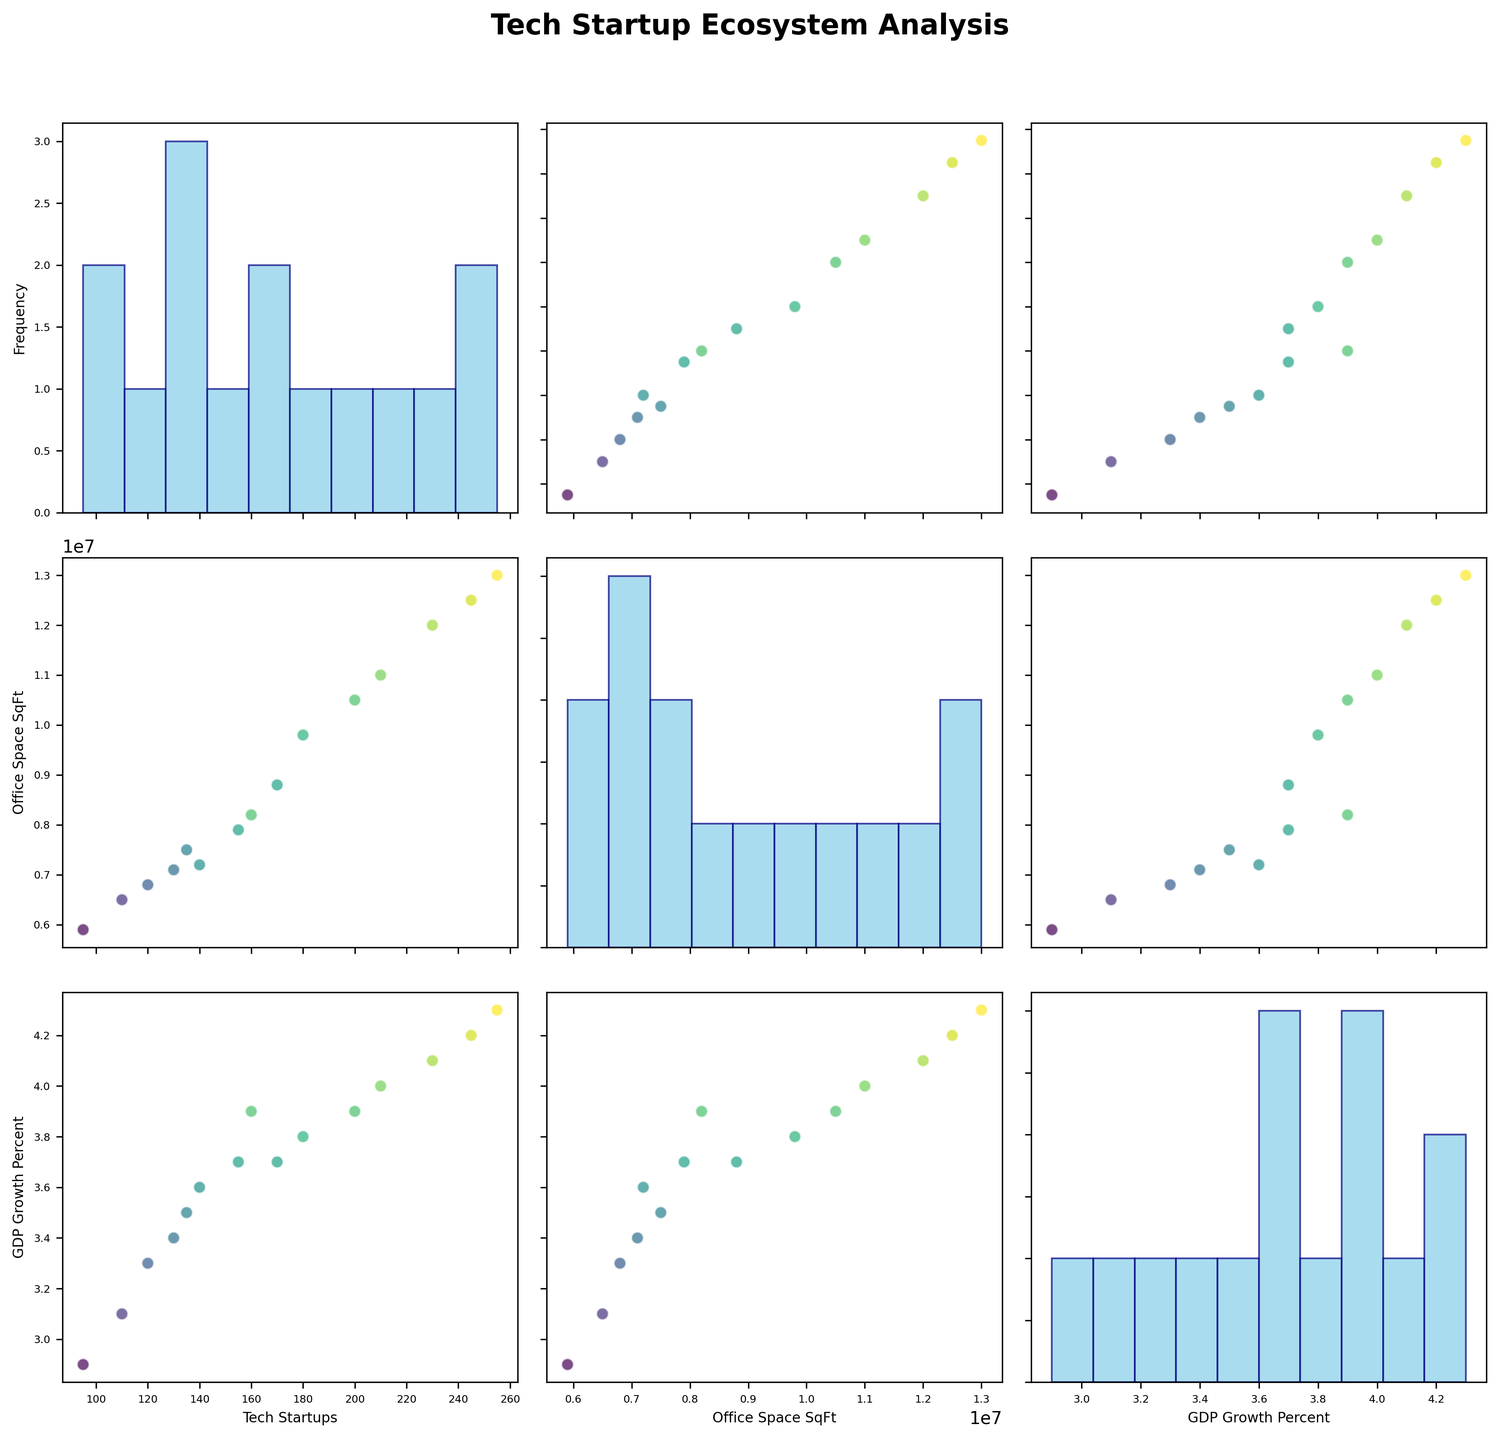What is the title of the figure? The title is located at the top of the figure. It provides an overview of what the figure is about. The title of this figure is "Tech Startup Ecosystem Analysis."
Answer: Tech Startup Ecosystem Analysis What is mapped to the color of the scatter points in the scatterplot matrix? The scatter points' color intensity varies, indicating a numeric variable. The legend or color bar must be inspected. Here, "GDP Growth Percent" is represented by the color of the scatter points.
Answer: GDP Growth Percent How many variables are plotted in this scatterplot matrix? The number of variables corresponds to the number of different scatter plots and histograms along the axes. Here, the figure examines three variables: "Tech Startups," "Office Space SqFt," and "GDP Growth Percent."
Answer: 3 Which city has the highest number of tech startups according to the figure? By examining the scatterplots or histograms of the "Tech Startups" variable, the city with the highest data point in this category can be identified. In this case, "Boston" has the highest number of tech startups.
Answer: Boston What can be inferred about the relationship between the number of tech startups and GDP growth? By observing the scatterplot between "Tech Startups" and "GDP Growth Percent," we can assess how these two variables relate. If the data points show an upward trend, we infer a positive correlation. There appears to be a positive relationship between the number of tech startups and GDP growth.
Answer: Positive relationship Is there an outlier in the amount of office space available? By examining the histogram for "Office Space SqFt," we can identify if there are any data points significantly different from others. An outlier may be an unusually high or low value. No distinct outliers appear in office space availability in the figure.
Answer: No Which city has the least amount of office space available? By referring to the scatter plots or histograms that show the distribution of "Office Space SqFt," the city with the minimum value can be identified. "Pittsburgh" has the least amount of office space available.
Answer: Pittsburgh How does GDP growth affect the number of tech startups? We need to look at the scatter plot that relates "GDP Growth Percent" to "Tech Startups." If there is a visible trend where higher GDP growth percentages correspond with a higher number of tech startups, it indicates a positive effect. The figure suggests that higher GDP growth positively affects the number of tech startups.
Answer: Positive effect What is the average amount of office space available (in square feet) in the cities? To find the average, calculate the sum of "Office Space SqFt" values and then divide by the number of cities. The sum is 12500000 + 9800000 + 7500000 + 8200000 + 6800000 + 7900000 + 7200000 + 6500000 + 5900000 + 7100000 + 11000000 + 12000000 + 13000000 + 10500000 + 8800000 = 134200000. Dividing this by 15 cities gives an average of 8,946,667 square feet.
Answer: 8,946,667 Which variable appears to have the strongest correlation with GDP growth? By examining the scatter plots where "GDP Growth Percent" is plotted against other variables, we look for the plot with the most discernible upward or downward trend. "Tech Startups" shows the strongest correlation with GDP growth.
Answer: Tech Startups 